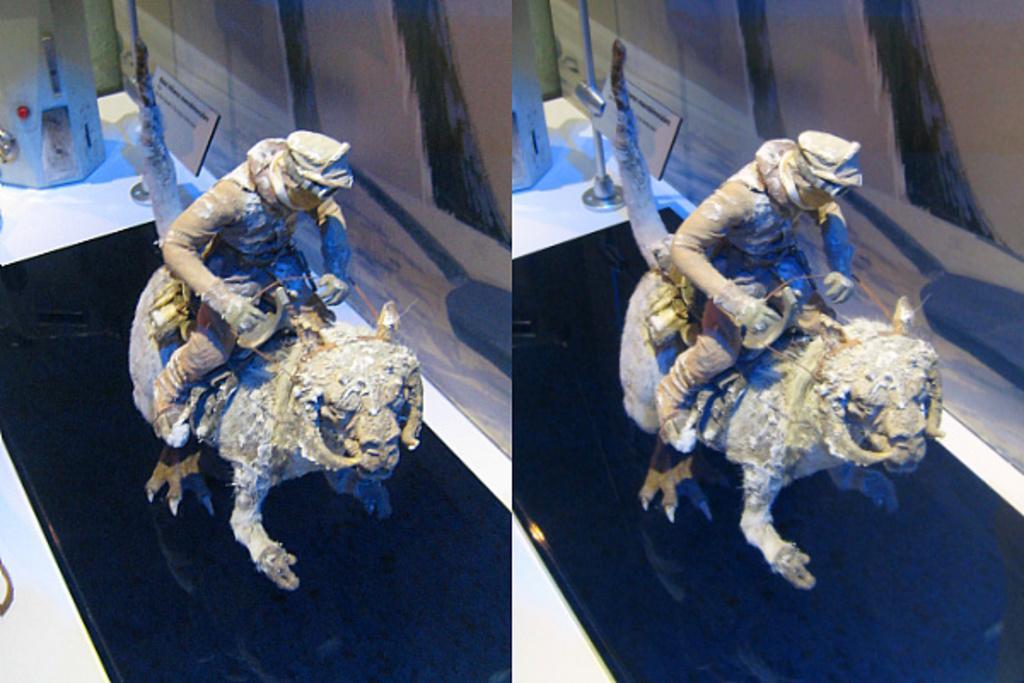Describe this image in one or two sentences. There are two images. In the first image, there is a person's statue sitting on the animal's statue which is on a slab near a wall and an object. And the second image is same as the first image. 